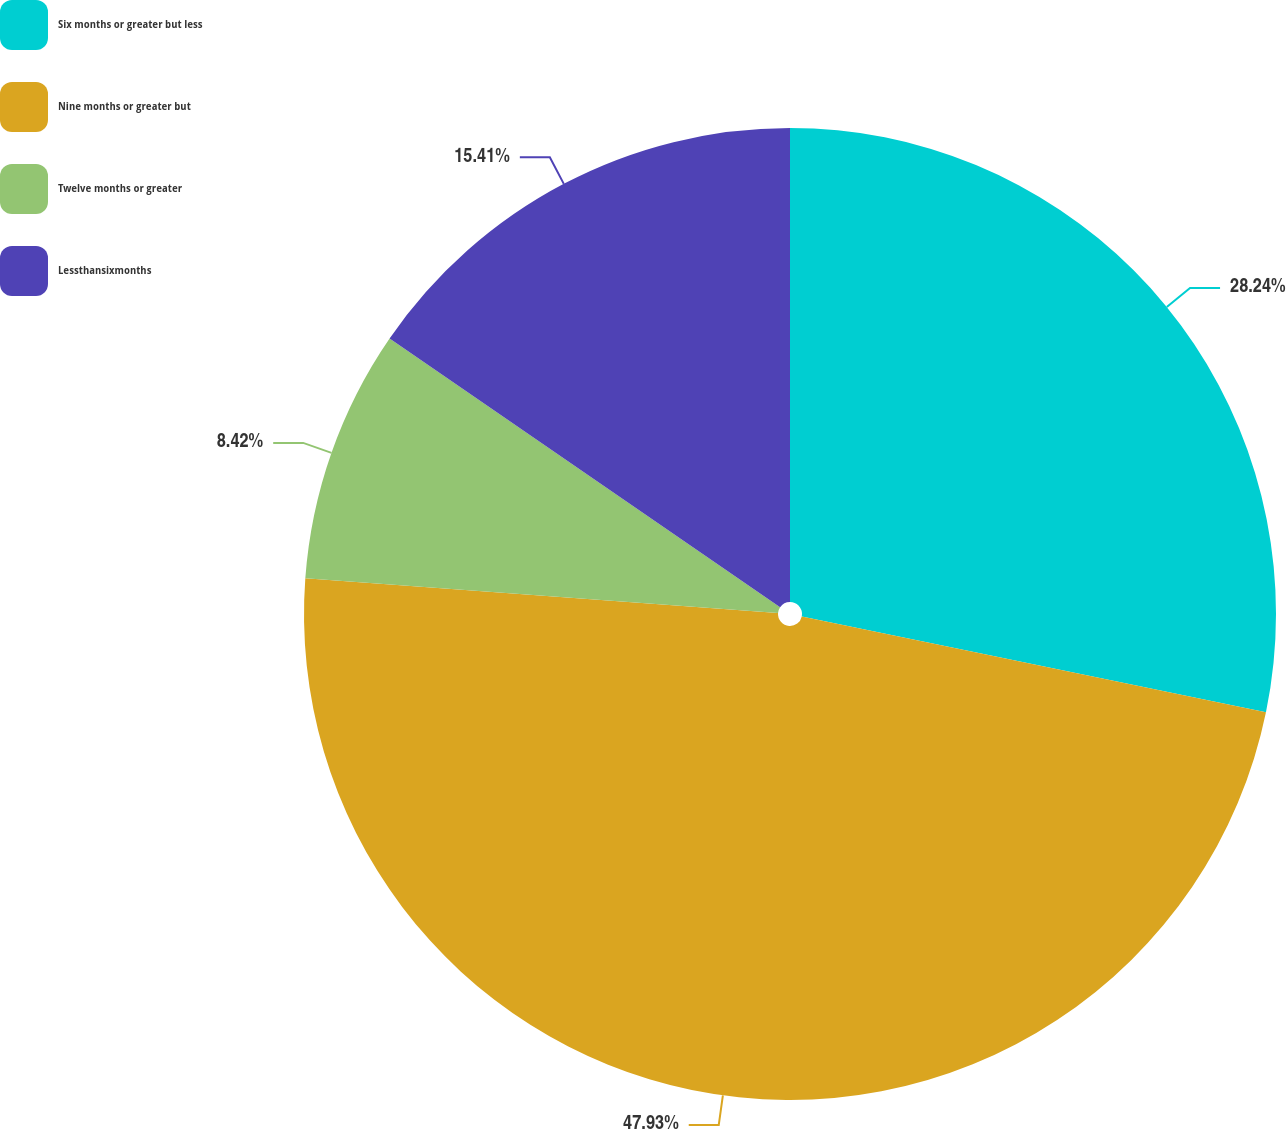<chart> <loc_0><loc_0><loc_500><loc_500><pie_chart><fcel>Six months or greater but less<fcel>Nine months or greater but<fcel>Twelve months or greater<fcel>Lessthansixmonths<nl><fcel>28.24%<fcel>47.93%<fcel>8.42%<fcel>15.41%<nl></chart> 